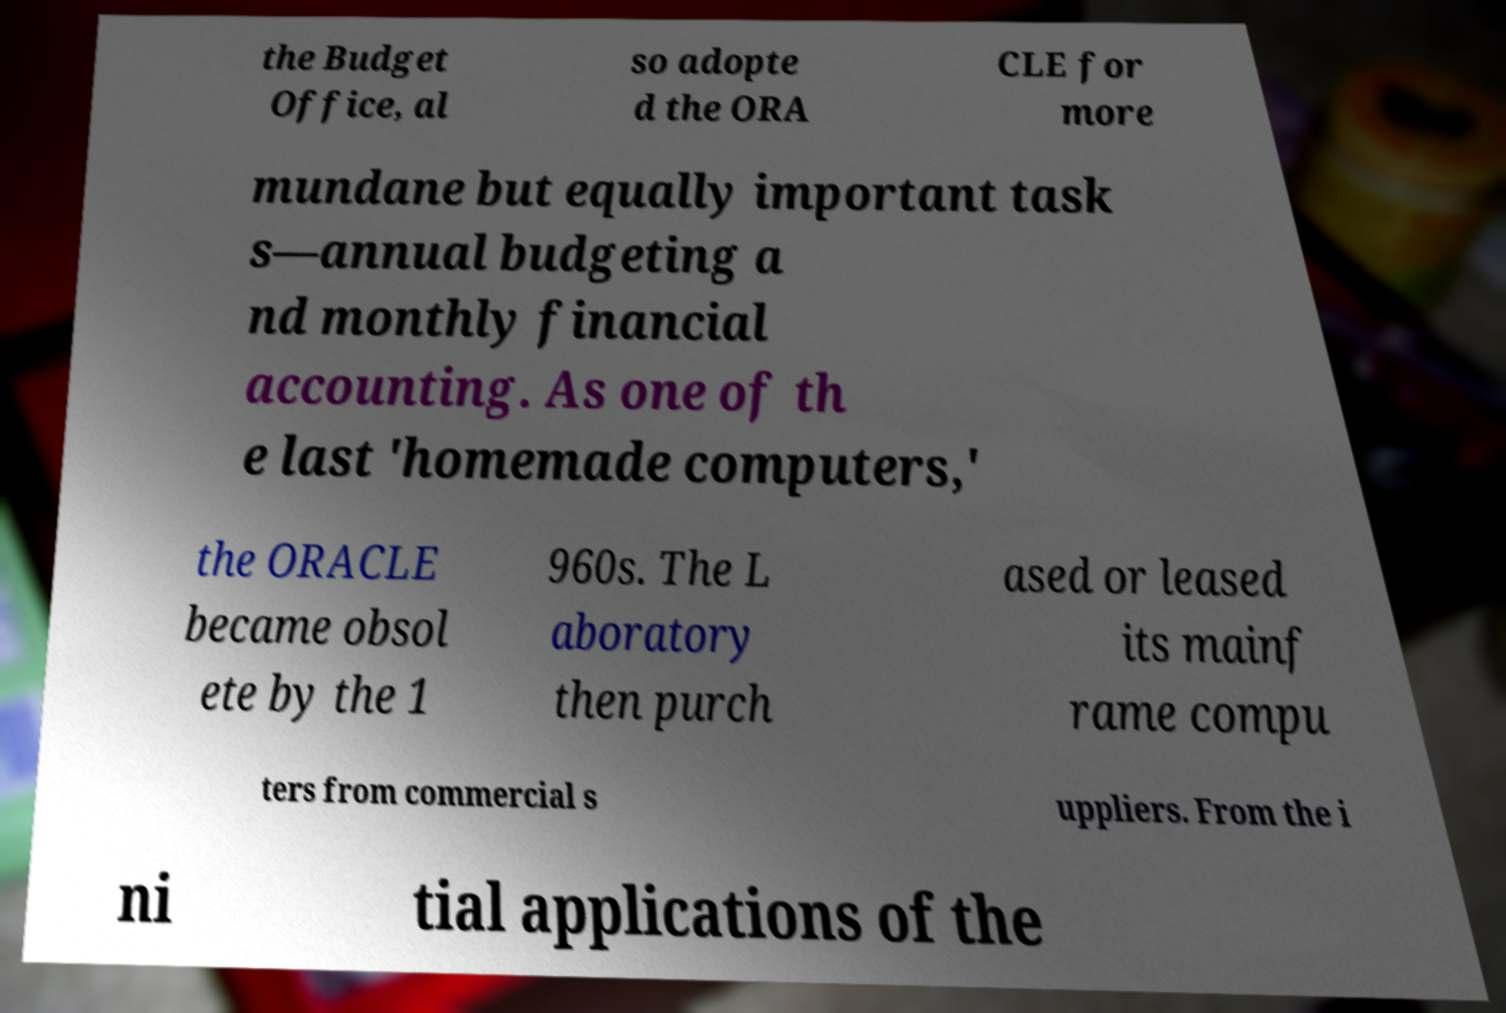For documentation purposes, I need the text within this image transcribed. Could you provide that? the Budget Office, al so adopte d the ORA CLE for more mundane but equally important task s—annual budgeting a nd monthly financial accounting. As one of th e last 'homemade computers,' the ORACLE became obsol ete by the 1 960s. The L aboratory then purch ased or leased its mainf rame compu ters from commercial s uppliers. From the i ni tial applications of the 